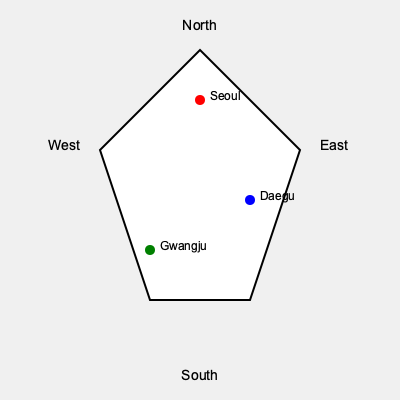Based on the simplified map of South Korea, if you were to travel from Seoul to Gwangju, in which general direction would you be moving? To determine the direction of travel from Seoul to Gwangju, we need to analyze their relative positions on the map:

1. Locate Seoul: It is represented by the red dot near the top of the map.
2. Locate Gwangju: It is represented by the green dot towards the bottom left of the map.
3. Compare their positions:
   - Seoul is further north than Gwangju
   - Gwangju is further west than Seoul
4. Combine these observations: Moving from Seoul to Gwangju involves going both south and west.
5. The general direction that combines south and west is southwest.

Therefore, traveling from Seoul to Gwangju would involve moving in a southwestern direction.
Answer: Southwest 